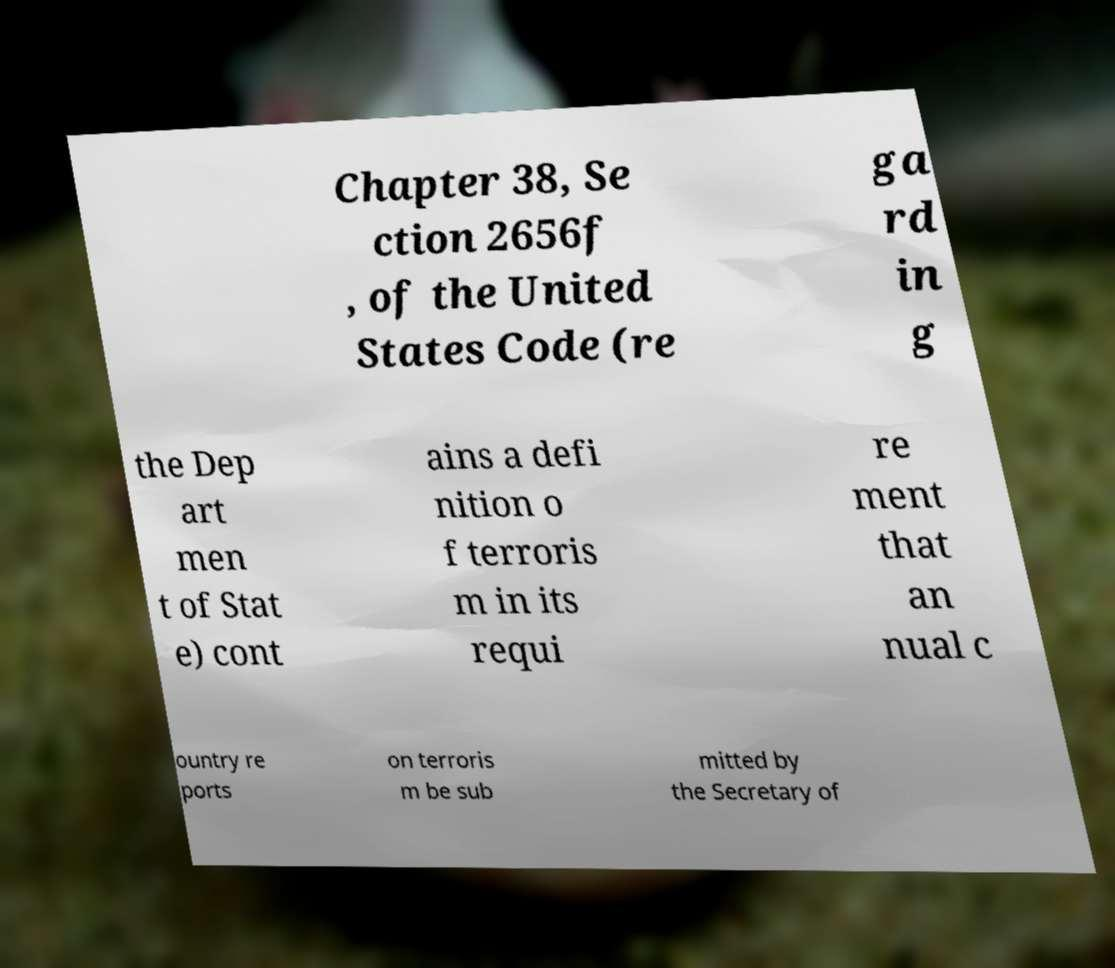Could you extract and type out the text from this image? Chapter 38, Se ction 2656f , of the United States Code (re ga rd in g the Dep art men t of Stat e) cont ains a defi nition o f terroris m in its requi re ment that an nual c ountry re ports on terroris m be sub mitted by the Secretary of 